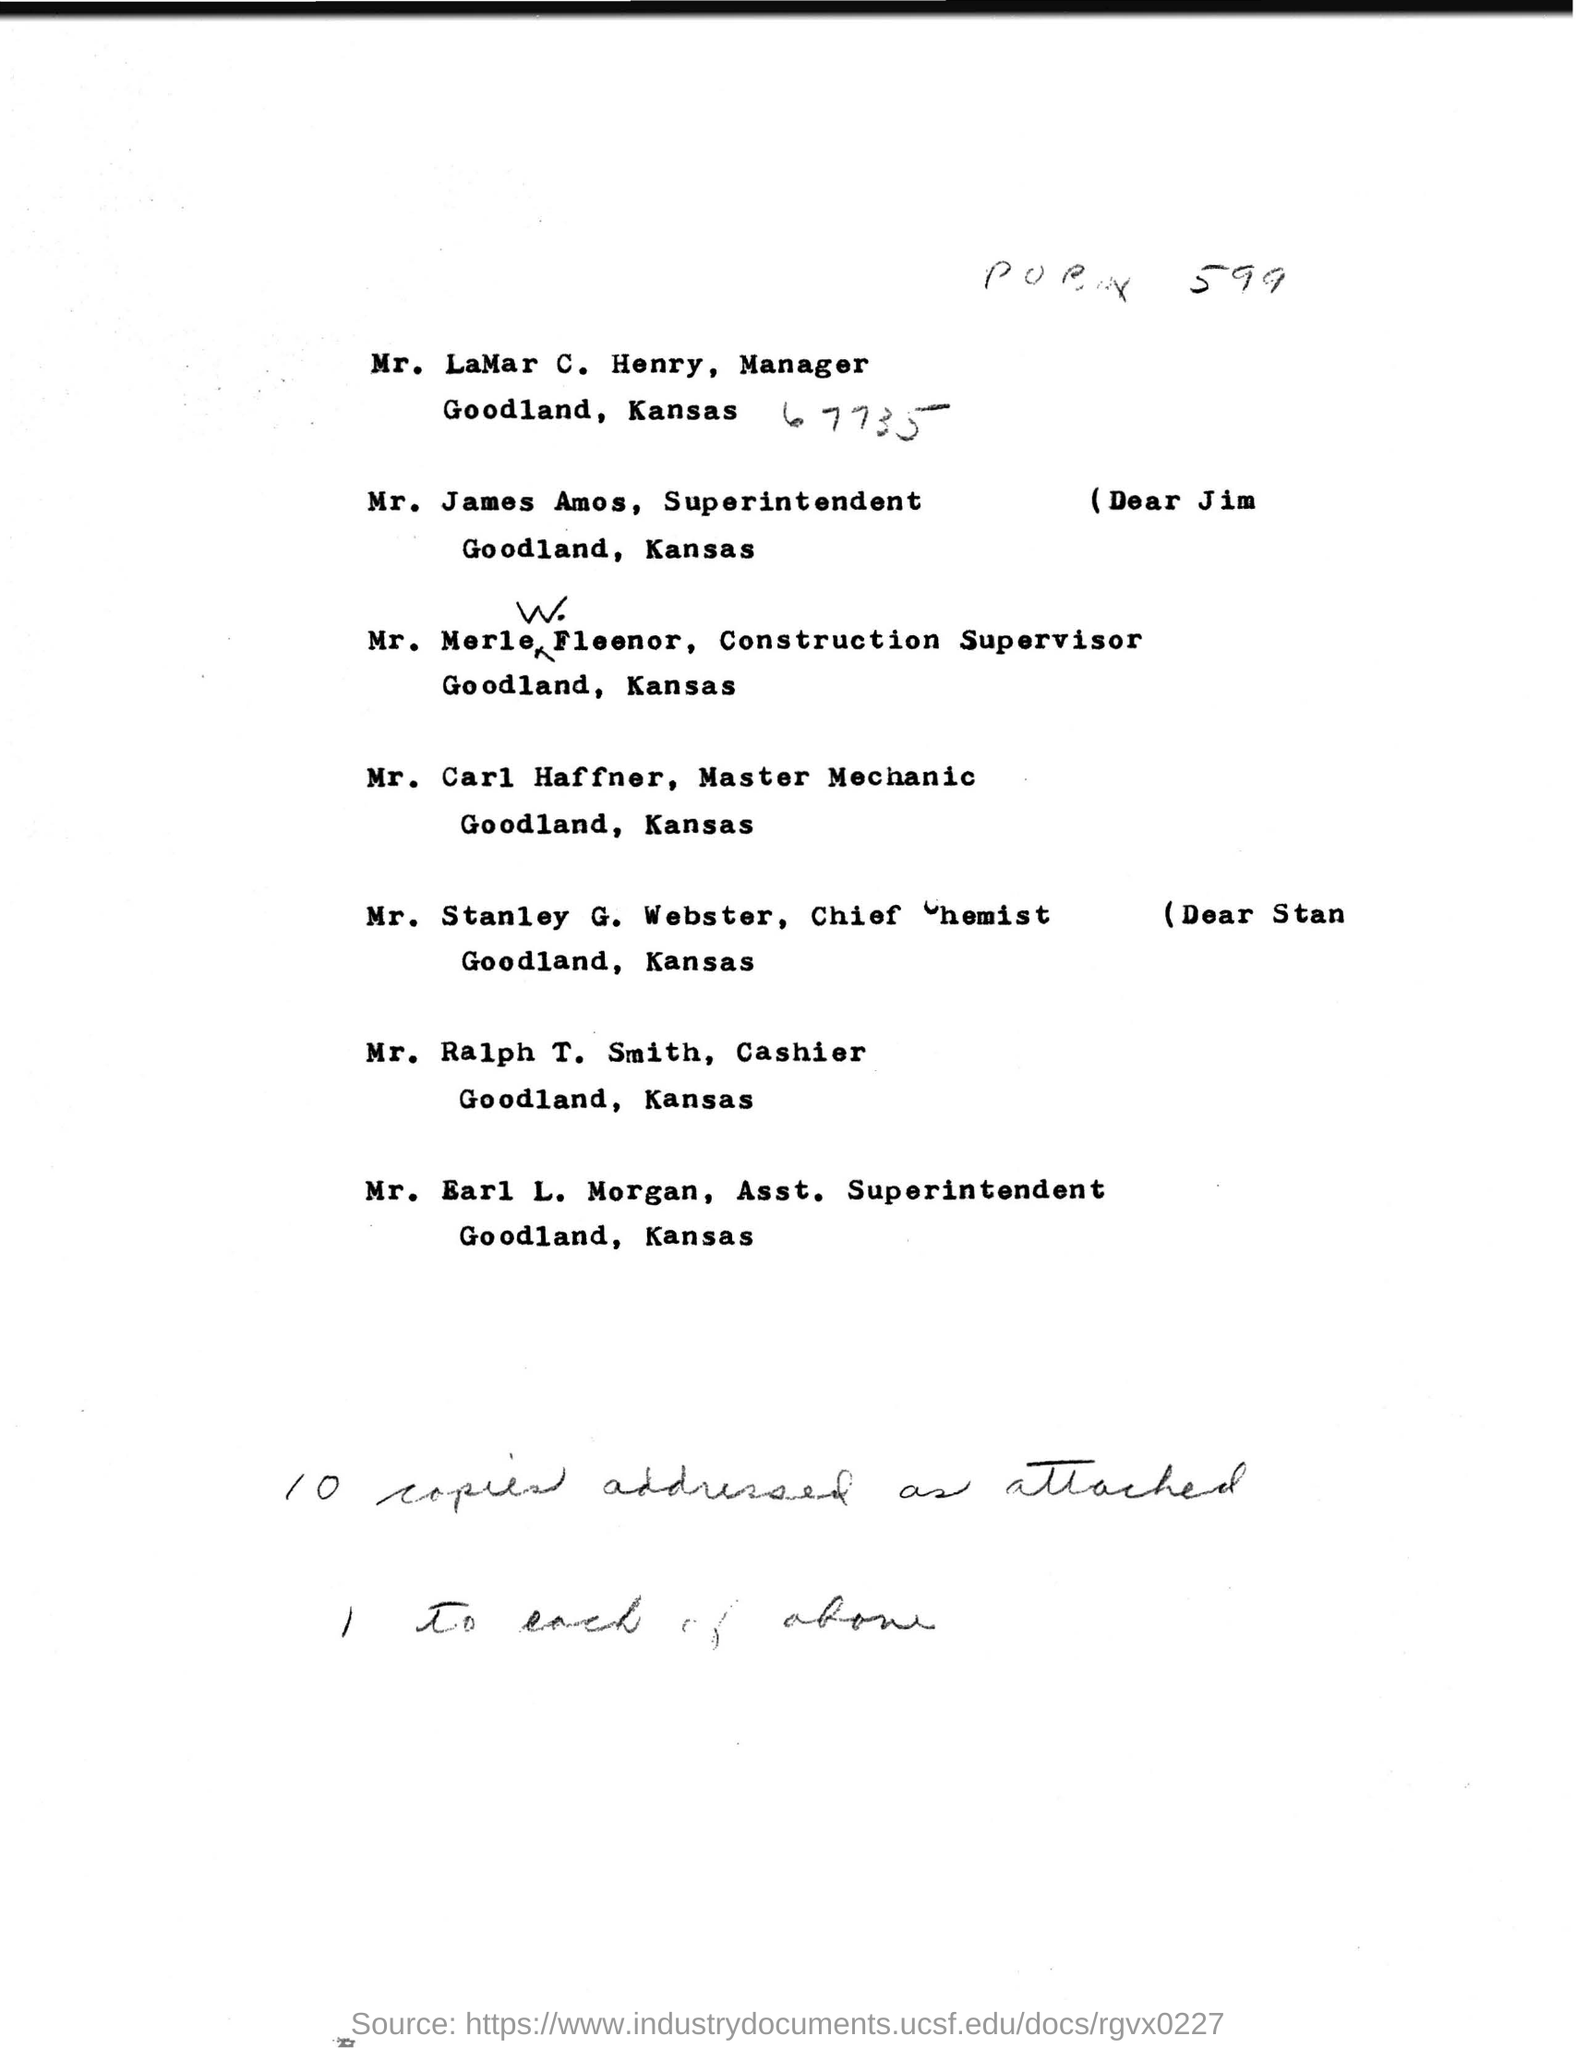Mention a couple of crucial points in this snapshot. The name of the chief chemist mentioned is Mr. Stanley G. Webster. The superintendent's name mentioned is Mr. James Amos. The cashier's name is Mr. Ralph T. Smith. The name of the master mechanic mentioned is Mr. Carl Haffner. The name of the assistant superintendent mentioned is Mr. Earl L. Morgan. 